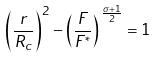Convert formula to latex. <formula><loc_0><loc_0><loc_500><loc_500>\left ( \frac { r } { R _ { c } } \right ) ^ { 2 } - \left ( \frac { F } { F ^ { * } } \right ) ^ { \, \frac { \sigma + 1 } { 2 } } = 1</formula> 